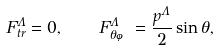Convert formula to latex. <formula><loc_0><loc_0><loc_500><loc_500>F ^ { \Lambda } _ { t r } = 0 , \quad F ^ { \Lambda } _ { \theta \varphi } = \frac { p ^ { \Lambda } } { 2 } \sin \theta ,</formula> 